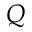Convert formula to latex. <formula><loc_0><loc_0><loc_500><loc_500>Q</formula> 